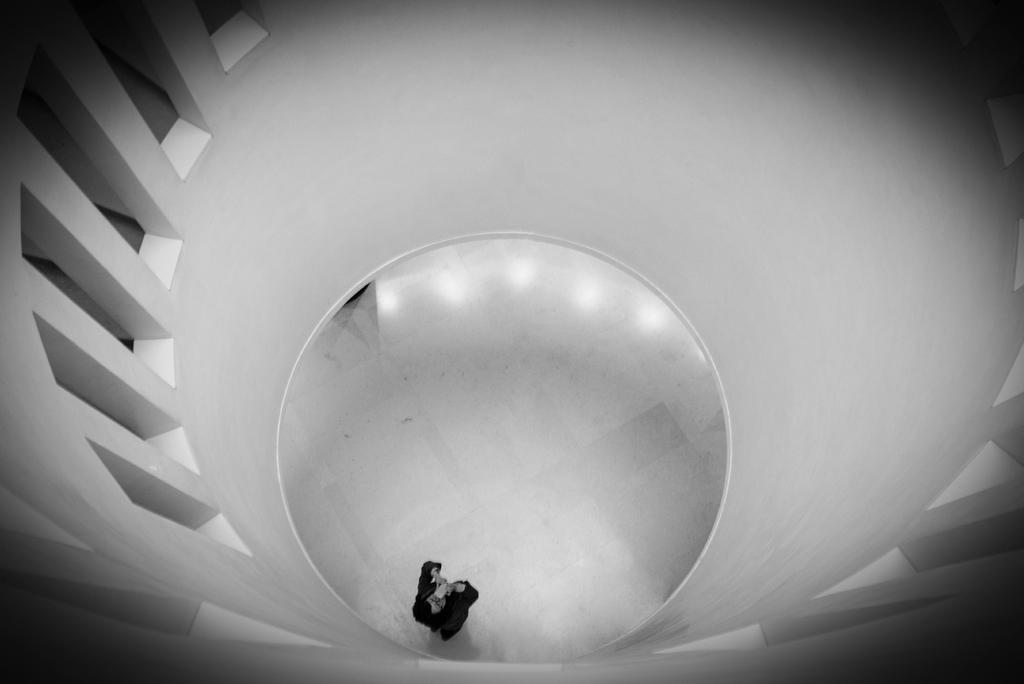What is the person in the image doing? The person is standing in the image and holding a cellphone. What can be seen near the person in the image? There is a rounded wall and stone pillars present around the wall in the image. What is the person's opinion on airplanes in the image? There is no information about the person's opinion on airplanes in the image. What type of pleasure can be seen in the image? There is no indication of pleasure in the image; it simply shows a person standing with a cellphone and a rounded wall with stone pillars. 